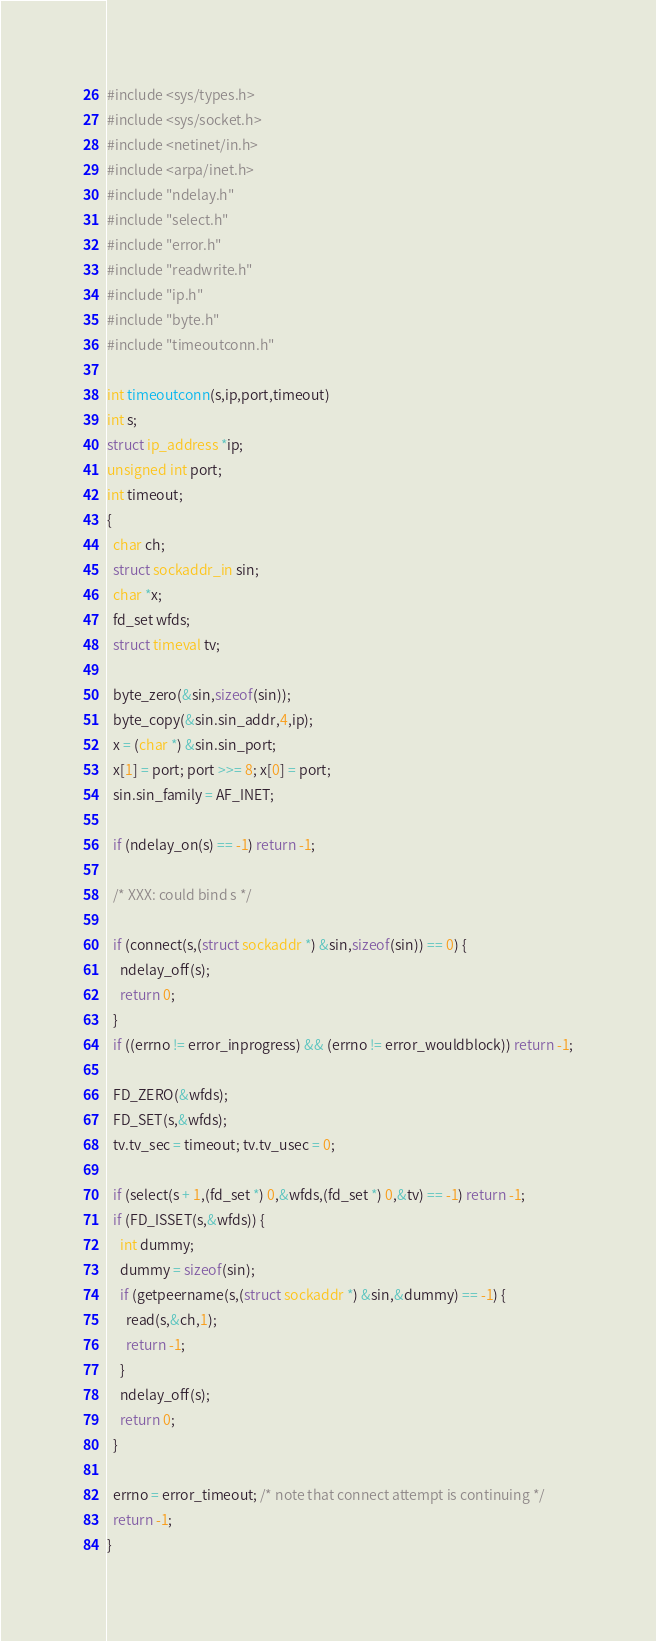Convert code to text. <code><loc_0><loc_0><loc_500><loc_500><_C_>#include <sys/types.h>
#include <sys/socket.h>
#include <netinet/in.h>
#include <arpa/inet.h>
#include "ndelay.h"
#include "select.h"
#include "error.h"
#include "readwrite.h"
#include "ip.h"
#include "byte.h"
#include "timeoutconn.h"

int timeoutconn(s,ip,port,timeout)
int s;
struct ip_address *ip;
unsigned int port;
int timeout;
{
  char ch;
  struct sockaddr_in sin;
  char *x;
  fd_set wfds;
  struct timeval tv;
 
  byte_zero(&sin,sizeof(sin));
  byte_copy(&sin.sin_addr,4,ip);
  x = (char *) &sin.sin_port;
  x[1] = port; port >>= 8; x[0] = port;
  sin.sin_family = AF_INET;
 
  if (ndelay_on(s) == -1) return -1;
 
  /* XXX: could bind s */
 
  if (connect(s,(struct sockaddr *) &sin,sizeof(sin)) == 0) {
    ndelay_off(s);
    return 0;
  }
  if ((errno != error_inprogress) && (errno != error_wouldblock)) return -1;
 
  FD_ZERO(&wfds);
  FD_SET(s,&wfds);
  tv.tv_sec = timeout; tv.tv_usec = 0;
 
  if (select(s + 1,(fd_set *) 0,&wfds,(fd_set *) 0,&tv) == -1) return -1;
  if (FD_ISSET(s,&wfds)) {
    int dummy;
    dummy = sizeof(sin);
    if (getpeername(s,(struct sockaddr *) &sin,&dummy) == -1) {
      read(s,&ch,1);
      return -1;
    }
    ndelay_off(s);
    return 0;
  }
 
  errno = error_timeout; /* note that connect attempt is continuing */
  return -1;
}
</code> 